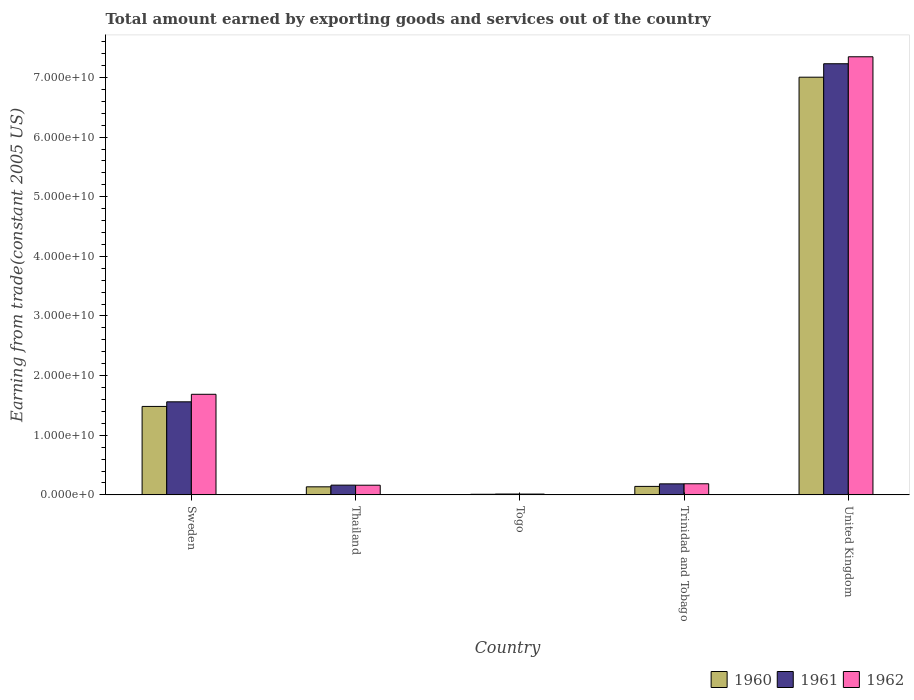How many groups of bars are there?
Ensure brevity in your answer.  5. How many bars are there on the 1st tick from the left?
Give a very brief answer. 3. How many bars are there on the 1st tick from the right?
Your response must be concise. 3. What is the label of the 3rd group of bars from the left?
Give a very brief answer. Togo. In how many cases, is the number of bars for a given country not equal to the number of legend labels?
Your answer should be very brief. 0. What is the total amount earned by exporting goods and services in 1961 in United Kingdom?
Your response must be concise. 7.23e+1. Across all countries, what is the maximum total amount earned by exporting goods and services in 1960?
Offer a terse response. 7.00e+1. Across all countries, what is the minimum total amount earned by exporting goods and services in 1960?
Give a very brief answer. 1.04e+08. In which country was the total amount earned by exporting goods and services in 1962 maximum?
Provide a short and direct response. United Kingdom. In which country was the total amount earned by exporting goods and services in 1960 minimum?
Ensure brevity in your answer.  Togo. What is the total total amount earned by exporting goods and services in 1962 in the graph?
Provide a succinct answer. 9.40e+1. What is the difference between the total amount earned by exporting goods and services in 1961 in Sweden and that in Togo?
Give a very brief answer. 1.55e+1. What is the difference between the total amount earned by exporting goods and services in 1961 in United Kingdom and the total amount earned by exporting goods and services in 1962 in Sweden?
Your answer should be compact. 5.54e+1. What is the average total amount earned by exporting goods and services in 1961 per country?
Keep it short and to the point. 1.83e+1. What is the difference between the total amount earned by exporting goods and services of/in 1961 and total amount earned by exporting goods and services of/in 1962 in Thailand?
Your response must be concise. 1.49e+07. What is the ratio of the total amount earned by exporting goods and services in 1961 in Sweden to that in Trinidad and Tobago?
Make the answer very short. 8.43. Is the total amount earned by exporting goods and services in 1961 in Togo less than that in United Kingdom?
Offer a terse response. Yes. Is the difference between the total amount earned by exporting goods and services in 1961 in Togo and United Kingdom greater than the difference between the total amount earned by exporting goods and services in 1962 in Togo and United Kingdom?
Give a very brief answer. Yes. What is the difference between the highest and the second highest total amount earned by exporting goods and services in 1962?
Give a very brief answer. -1.50e+1. What is the difference between the highest and the lowest total amount earned by exporting goods and services in 1960?
Provide a short and direct response. 6.99e+1. In how many countries, is the total amount earned by exporting goods and services in 1961 greater than the average total amount earned by exporting goods and services in 1961 taken over all countries?
Offer a very short reply. 1. Is the sum of the total amount earned by exporting goods and services in 1961 in Sweden and Thailand greater than the maximum total amount earned by exporting goods and services in 1960 across all countries?
Your response must be concise. No. How many bars are there?
Offer a terse response. 15. How many countries are there in the graph?
Your response must be concise. 5. Are the values on the major ticks of Y-axis written in scientific E-notation?
Keep it short and to the point. Yes. Does the graph contain any zero values?
Offer a terse response. No. Where does the legend appear in the graph?
Make the answer very short. Bottom right. What is the title of the graph?
Provide a short and direct response. Total amount earned by exporting goods and services out of the country. What is the label or title of the X-axis?
Offer a very short reply. Country. What is the label or title of the Y-axis?
Your answer should be compact. Earning from trade(constant 2005 US). What is the Earning from trade(constant 2005 US) of 1960 in Sweden?
Keep it short and to the point. 1.48e+1. What is the Earning from trade(constant 2005 US) of 1961 in Sweden?
Keep it short and to the point. 1.56e+1. What is the Earning from trade(constant 2005 US) of 1962 in Sweden?
Provide a short and direct response. 1.69e+1. What is the Earning from trade(constant 2005 US) of 1960 in Thailand?
Provide a short and direct response. 1.35e+09. What is the Earning from trade(constant 2005 US) in 1961 in Thailand?
Make the answer very short. 1.64e+09. What is the Earning from trade(constant 2005 US) of 1962 in Thailand?
Ensure brevity in your answer.  1.62e+09. What is the Earning from trade(constant 2005 US) in 1960 in Togo?
Give a very brief answer. 1.04e+08. What is the Earning from trade(constant 2005 US) of 1961 in Togo?
Keep it short and to the point. 1.46e+08. What is the Earning from trade(constant 2005 US) of 1962 in Togo?
Give a very brief answer. 1.39e+08. What is the Earning from trade(constant 2005 US) of 1960 in Trinidad and Tobago?
Give a very brief answer. 1.42e+09. What is the Earning from trade(constant 2005 US) in 1961 in Trinidad and Tobago?
Offer a very short reply. 1.85e+09. What is the Earning from trade(constant 2005 US) of 1962 in Trinidad and Tobago?
Provide a short and direct response. 1.86e+09. What is the Earning from trade(constant 2005 US) of 1960 in United Kingdom?
Offer a very short reply. 7.00e+1. What is the Earning from trade(constant 2005 US) of 1961 in United Kingdom?
Give a very brief answer. 7.23e+1. What is the Earning from trade(constant 2005 US) in 1962 in United Kingdom?
Give a very brief answer. 7.35e+1. Across all countries, what is the maximum Earning from trade(constant 2005 US) in 1960?
Your answer should be compact. 7.00e+1. Across all countries, what is the maximum Earning from trade(constant 2005 US) in 1961?
Your answer should be compact. 7.23e+1. Across all countries, what is the maximum Earning from trade(constant 2005 US) in 1962?
Provide a short and direct response. 7.35e+1. Across all countries, what is the minimum Earning from trade(constant 2005 US) of 1960?
Provide a succinct answer. 1.04e+08. Across all countries, what is the minimum Earning from trade(constant 2005 US) of 1961?
Your response must be concise. 1.46e+08. Across all countries, what is the minimum Earning from trade(constant 2005 US) of 1962?
Provide a succinct answer. 1.39e+08. What is the total Earning from trade(constant 2005 US) in 1960 in the graph?
Ensure brevity in your answer.  8.78e+1. What is the total Earning from trade(constant 2005 US) in 1961 in the graph?
Offer a very short reply. 9.15e+1. What is the total Earning from trade(constant 2005 US) of 1962 in the graph?
Your answer should be very brief. 9.40e+1. What is the difference between the Earning from trade(constant 2005 US) in 1960 in Sweden and that in Thailand?
Provide a succinct answer. 1.35e+1. What is the difference between the Earning from trade(constant 2005 US) in 1961 in Sweden and that in Thailand?
Your answer should be very brief. 1.40e+1. What is the difference between the Earning from trade(constant 2005 US) of 1962 in Sweden and that in Thailand?
Keep it short and to the point. 1.52e+1. What is the difference between the Earning from trade(constant 2005 US) in 1960 in Sweden and that in Togo?
Your response must be concise. 1.47e+1. What is the difference between the Earning from trade(constant 2005 US) in 1961 in Sweden and that in Togo?
Your answer should be very brief. 1.55e+1. What is the difference between the Earning from trade(constant 2005 US) in 1962 in Sweden and that in Togo?
Your answer should be compact. 1.67e+1. What is the difference between the Earning from trade(constant 2005 US) of 1960 in Sweden and that in Trinidad and Tobago?
Your answer should be very brief. 1.34e+1. What is the difference between the Earning from trade(constant 2005 US) of 1961 in Sweden and that in Trinidad and Tobago?
Ensure brevity in your answer.  1.38e+1. What is the difference between the Earning from trade(constant 2005 US) in 1962 in Sweden and that in Trinidad and Tobago?
Offer a very short reply. 1.50e+1. What is the difference between the Earning from trade(constant 2005 US) in 1960 in Sweden and that in United Kingdom?
Keep it short and to the point. -5.52e+1. What is the difference between the Earning from trade(constant 2005 US) of 1961 in Sweden and that in United Kingdom?
Make the answer very short. -5.67e+1. What is the difference between the Earning from trade(constant 2005 US) in 1962 in Sweden and that in United Kingdom?
Your answer should be compact. -5.66e+1. What is the difference between the Earning from trade(constant 2005 US) in 1960 in Thailand and that in Togo?
Ensure brevity in your answer.  1.25e+09. What is the difference between the Earning from trade(constant 2005 US) in 1961 in Thailand and that in Togo?
Provide a succinct answer. 1.49e+09. What is the difference between the Earning from trade(constant 2005 US) in 1962 in Thailand and that in Togo?
Your answer should be compact. 1.48e+09. What is the difference between the Earning from trade(constant 2005 US) of 1960 in Thailand and that in Trinidad and Tobago?
Your answer should be very brief. -6.88e+07. What is the difference between the Earning from trade(constant 2005 US) of 1961 in Thailand and that in Trinidad and Tobago?
Your response must be concise. -2.13e+08. What is the difference between the Earning from trade(constant 2005 US) of 1962 in Thailand and that in Trinidad and Tobago?
Offer a terse response. -2.41e+08. What is the difference between the Earning from trade(constant 2005 US) in 1960 in Thailand and that in United Kingdom?
Your answer should be compact. -6.87e+1. What is the difference between the Earning from trade(constant 2005 US) of 1961 in Thailand and that in United Kingdom?
Give a very brief answer. -7.07e+1. What is the difference between the Earning from trade(constant 2005 US) of 1962 in Thailand and that in United Kingdom?
Offer a terse response. -7.18e+1. What is the difference between the Earning from trade(constant 2005 US) of 1960 in Togo and that in Trinidad and Tobago?
Keep it short and to the point. -1.32e+09. What is the difference between the Earning from trade(constant 2005 US) in 1961 in Togo and that in Trinidad and Tobago?
Keep it short and to the point. -1.70e+09. What is the difference between the Earning from trade(constant 2005 US) in 1962 in Togo and that in Trinidad and Tobago?
Keep it short and to the point. -1.73e+09. What is the difference between the Earning from trade(constant 2005 US) in 1960 in Togo and that in United Kingdom?
Provide a short and direct response. -6.99e+1. What is the difference between the Earning from trade(constant 2005 US) in 1961 in Togo and that in United Kingdom?
Provide a short and direct response. -7.22e+1. What is the difference between the Earning from trade(constant 2005 US) in 1962 in Togo and that in United Kingdom?
Provide a short and direct response. -7.33e+1. What is the difference between the Earning from trade(constant 2005 US) of 1960 in Trinidad and Tobago and that in United Kingdom?
Provide a succinct answer. -6.86e+1. What is the difference between the Earning from trade(constant 2005 US) of 1961 in Trinidad and Tobago and that in United Kingdom?
Give a very brief answer. -7.04e+1. What is the difference between the Earning from trade(constant 2005 US) of 1962 in Trinidad and Tobago and that in United Kingdom?
Provide a short and direct response. -7.16e+1. What is the difference between the Earning from trade(constant 2005 US) of 1960 in Sweden and the Earning from trade(constant 2005 US) of 1961 in Thailand?
Give a very brief answer. 1.32e+1. What is the difference between the Earning from trade(constant 2005 US) in 1960 in Sweden and the Earning from trade(constant 2005 US) in 1962 in Thailand?
Keep it short and to the point. 1.32e+1. What is the difference between the Earning from trade(constant 2005 US) of 1961 in Sweden and the Earning from trade(constant 2005 US) of 1962 in Thailand?
Offer a terse response. 1.40e+1. What is the difference between the Earning from trade(constant 2005 US) of 1960 in Sweden and the Earning from trade(constant 2005 US) of 1961 in Togo?
Give a very brief answer. 1.47e+1. What is the difference between the Earning from trade(constant 2005 US) of 1960 in Sweden and the Earning from trade(constant 2005 US) of 1962 in Togo?
Make the answer very short. 1.47e+1. What is the difference between the Earning from trade(constant 2005 US) in 1961 in Sweden and the Earning from trade(constant 2005 US) in 1962 in Togo?
Provide a short and direct response. 1.55e+1. What is the difference between the Earning from trade(constant 2005 US) in 1960 in Sweden and the Earning from trade(constant 2005 US) in 1961 in Trinidad and Tobago?
Ensure brevity in your answer.  1.30e+1. What is the difference between the Earning from trade(constant 2005 US) of 1960 in Sweden and the Earning from trade(constant 2005 US) of 1962 in Trinidad and Tobago?
Ensure brevity in your answer.  1.30e+1. What is the difference between the Earning from trade(constant 2005 US) of 1961 in Sweden and the Earning from trade(constant 2005 US) of 1962 in Trinidad and Tobago?
Offer a terse response. 1.37e+1. What is the difference between the Earning from trade(constant 2005 US) of 1960 in Sweden and the Earning from trade(constant 2005 US) of 1961 in United Kingdom?
Your answer should be compact. -5.75e+1. What is the difference between the Earning from trade(constant 2005 US) of 1960 in Sweden and the Earning from trade(constant 2005 US) of 1962 in United Kingdom?
Keep it short and to the point. -5.86e+1. What is the difference between the Earning from trade(constant 2005 US) in 1961 in Sweden and the Earning from trade(constant 2005 US) in 1962 in United Kingdom?
Your response must be concise. -5.79e+1. What is the difference between the Earning from trade(constant 2005 US) of 1960 in Thailand and the Earning from trade(constant 2005 US) of 1961 in Togo?
Offer a terse response. 1.21e+09. What is the difference between the Earning from trade(constant 2005 US) of 1960 in Thailand and the Earning from trade(constant 2005 US) of 1962 in Togo?
Ensure brevity in your answer.  1.22e+09. What is the difference between the Earning from trade(constant 2005 US) in 1961 in Thailand and the Earning from trade(constant 2005 US) in 1962 in Togo?
Provide a short and direct response. 1.50e+09. What is the difference between the Earning from trade(constant 2005 US) in 1960 in Thailand and the Earning from trade(constant 2005 US) in 1961 in Trinidad and Tobago?
Ensure brevity in your answer.  -4.96e+08. What is the difference between the Earning from trade(constant 2005 US) in 1960 in Thailand and the Earning from trade(constant 2005 US) in 1962 in Trinidad and Tobago?
Your answer should be very brief. -5.09e+08. What is the difference between the Earning from trade(constant 2005 US) of 1961 in Thailand and the Earning from trade(constant 2005 US) of 1962 in Trinidad and Tobago?
Keep it short and to the point. -2.26e+08. What is the difference between the Earning from trade(constant 2005 US) in 1960 in Thailand and the Earning from trade(constant 2005 US) in 1961 in United Kingdom?
Provide a succinct answer. -7.09e+1. What is the difference between the Earning from trade(constant 2005 US) of 1960 in Thailand and the Earning from trade(constant 2005 US) of 1962 in United Kingdom?
Offer a very short reply. -7.21e+1. What is the difference between the Earning from trade(constant 2005 US) of 1961 in Thailand and the Earning from trade(constant 2005 US) of 1962 in United Kingdom?
Offer a terse response. -7.18e+1. What is the difference between the Earning from trade(constant 2005 US) in 1960 in Togo and the Earning from trade(constant 2005 US) in 1961 in Trinidad and Tobago?
Provide a short and direct response. -1.75e+09. What is the difference between the Earning from trade(constant 2005 US) in 1960 in Togo and the Earning from trade(constant 2005 US) in 1962 in Trinidad and Tobago?
Give a very brief answer. -1.76e+09. What is the difference between the Earning from trade(constant 2005 US) in 1961 in Togo and the Earning from trade(constant 2005 US) in 1962 in Trinidad and Tobago?
Ensure brevity in your answer.  -1.72e+09. What is the difference between the Earning from trade(constant 2005 US) in 1960 in Togo and the Earning from trade(constant 2005 US) in 1961 in United Kingdom?
Your response must be concise. -7.22e+1. What is the difference between the Earning from trade(constant 2005 US) of 1960 in Togo and the Earning from trade(constant 2005 US) of 1962 in United Kingdom?
Make the answer very short. -7.34e+1. What is the difference between the Earning from trade(constant 2005 US) of 1961 in Togo and the Earning from trade(constant 2005 US) of 1962 in United Kingdom?
Your answer should be compact. -7.33e+1. What is the difference between the Earning from trade(constant 2005 US) in 1960 in Trinidad and Tobago and the Earning from trade(constant 2005 US) in 1961 in United Kingdom?
Offer a terse response. -7.09e+1. What is the difference between the Earning from trade(constant 2005 US) of 1960 in Trinidad and Tobago and the Earning from trade(constant 2005 US) of 1962 in United Kingdom?
Ensure brevity in your answer.  -7.20e+1. What is the difference between the Earning from trade(constant 2005 US) in 1961 in Trinidad and Tobago and the Earning from trade(constant 2005 US) in 1962 in United Kingdom?
Your answer should be very brief. -7.16e+1. What is the average Earning from trade(constant 2005 US) of 1960 per country?
Your answer should be compact. 1.76e+1. What is the average Earning from trade(constant 2005 US) in 1961 per country?
Your answer should be very brief. 1.83e+1. What is the average Earning from trade(constant 2005 US) in 1962 per country?
Your answer should be compact. 1.88e+1. What is the difference between the Earning from trade(constant 2005 US) in 1960 and Earning from trade(constant 2005 US) in 1961 in Sweden?
Provide a succinct answer. -7.72e+08. What is the difference between the Earning from trade(constant 2005 US) of 1960 and Earning from trade(constant 2005 US) of 1962 in Sweden?
Provide a succinct answer. -2.03e+09. What is the difference between the Earning from trade(constant 2005 US) of 1961 and Earning from trade(constant 2005 US) of 1962 in Sweden?
Offer a terse response. -1.26e+09. What is the difference between the Earning from trade(constant 2005 US) of 1960 and Earning from trade(constant 2005 US) of 1961 in Thailand?
Provide a succinct answer. -2.83e+08. What is the difference between the Earning from trade(constant 2005 US) of 1960 and Earning from trade(constant 2005 US) of 1962 in Thailand?
Provide a short and direct response. -2.68e+08. What is the difference between the Earning from trade(constant 2005 US) of 1961 and Earning from trade(constant 2005 US) of 1962 in Thailand?
Your answer should be very brief. 1.49e+07. What is the difference between the Earning from trade(constant 2005 US) of 1960 and Earning from trade(constant 2005 US) of 1961 in Togo?
Ensure brevity in your answer.  -4.26e+07. What is the difference between the Earning from trade(constant 2005 US) in 1960 and Earning from trade(constant 2005 US) in 1962 in Togo?
Offer a very short reply. -3.51e+07. What is the difference between the Earning from trade(constant 2005 US) in 1961 and Earning from trade(constant 2005 US) in 1962 in Togo?
Give a very brief answer. 7.52e+06. What is the difference between the Earning from trade(constant 2005 US) of 1960 and Earning from trade(constant 2005 US) of 1961 in Trinidad and Tobago?
Provide a short and direct response. -4.27e+08. What is the difference between the Earning from trade(constant 2005 US) of 1960 and Earning from trade(constant 2005 US) of 1962 in Trinidad and Tobago?
Your answer should be very brief. -4.40e+08. What is the difference between the Earning from trade(constant 2005 US) in 1961 and Earning from trade(constant 2005 US) in 1962 in Trinidad and Tobago?
Offer a very short reply. -1.34e+07. What is the difference between the Earning from trade(constant 2005 US) in 1960 and Earning from trade(constant 2005 US) in 1961 in United Kingdom?
Ensure brevity in your answer.  -2.26e+09. What is the difference between the Earning from trade(constant 2005 US) of 1960 and Earning from trade(constant 2005 US) of 1962 in United Kingdom?
Give a very brief answer. -3.42e+09. What is the difference between the Earning from trade(constant 2005 US) in 1961 and Earning from trade(constant 2005 US) in 1962 in United Kingdom?
Your answer should be compact. -1.17e+09. What is the ratio of the Earning from trade(constant 2005 US) in 1960 in Sweden to that in Thailand?
Your response must be concise. 10.95. What is the ratio of the Earning from trade(constant 2005 US) of 1961 in Sweden to that in Thailand?
Keep it short and to the point. 9.53. What is the ratio of the Earning from trade(constant 2005 US) of 1962 in Sweden to that in Thailand?
Your response must be concise. 10.4. What is the ratio of the Earning from trade(constant 2005 US) in 1960 in Sweden to that in Togo?
Your answer should be compact. 142.92. What is the ratio of the Earning from trade(constant 2005 US) in 1961 in Sweden to that in Togo?
Your response must be concise. 106.59. What is the ratio of the Earning from trade(constant 2005 US) in 1962 in Sweden to that in Togo?
Your answer should be very brief. 121.45. What is the ratio of the Earning from trade(constant 2005 US) in 1960 in Sweden to that in Trinidad and Tobago?
Give a very brief answer. 10.42. What is the ratio of the Earning from trade(constant 2005 US) of 1961 in Sweden to that in Trinidad and Tobago?
Your answer should be compact. 8.43. What is the ratio of the Earning from trade(constant 2005 US) in 1962 in Sweden to that in Trinidad and Tobago?
Offer a very short reply. 9.05. What is the ratio of the Earning from trade(constant 2005 US) of 1960 in Sweden to that in United Kingdom?
Your response must be concise. 0.21. What is the ratio of the Earning from trade(constant 2005 US) in 1961 in Sweden to that in United Kingdom?
Offer a terse response. 0.22. What is the ratio of the Earning from trade(constant 2005 US) of 1962 in Sweden to that in United Kingdom?
Your answer should be very brief. 0.23. What is the ratio of the Earning from trade(constant 2005 US) in 1960 in Thailand to that in Togo?
Provide a succinct answer. 13.05. What is the ratio of the Earning from trade(constant 2005 US) of 1961 in Thailand to that in Togo?
Your answer should be compact. 11.18. What is the ratio of the Earning from trade(constant 2005 US) of 1962 in Thailand to that in Togo?
Keep it short and to the point. 11.68. What is the ratio of the Earning from trade(constant 2005 US) of 1960 in Thailand to that in Trinidad and Tobago?
Provide a short and direct response. 0.95. What is the ratio of the Earning from trade(constant 2005 US) of 1961 in Thailand to that in Trinidad and Tobago?
Your response must be concise. 0.88. What is the ratio of the Earning from trade(constant 2005 US) of 1962 in Thailand to that in Trinidad and Tobago?
Offer a very short reply. 0.87. What is the ratio of the Earning from trade(constant 2005 US) of 1960 in Thailand to that in United Kingdom?
Offer a very short reply. 0.02. What is the ratio of the Earning from trade(constant 2005 US) of 1961 in Thailand to that in United Kingdom?
Offer a very short reply. 0.02. What is the ratio of the Earning from trade(constant 2005 US) of 1962 in Thailand to that in United Kingdom?
Offer a very short reply. 0.02. What is the ratio of the Earning from trade(constant 2005 US) in 1960 in Togo to that in Trinidad and Tobago?
Offer a very short reply. 0.07. What is the ratio of the Earning from trade(constant 2005 US) of 1961 in Togo to that in Trinidad and Tobago?
Provide a short and direct response. 0.08. What is the ratio of the Earning from trade(constant 2005 US) in 1962 in Togo to that in Trinidad and Tobago?
Ensure brevity in your answer.  0.07. What is the ratio of the Earning from trade(constant 2005 US) in 1960 in Togo to that in United Kingdom?
Your answer should be compact. 0. What is the ratio of the Earning from trade(constant 2005 US) of 1961 in Togo to that in United Kingdom?
Your response must be concise. 0. What is the ratio of the Earning from trade(constant 2005 US) in 1962 in Togo to that in United Kingdom?
Your answer should be very brief. 0. What is the ratio of the Earning from trade(constant 2005 US) in 1960 in Trinidad and Tobago to that in United Kingdom?
Provide a succinct answer. 0.02. What is the ratio of the Earning from trade(constant 2005 US) in 1961 in Trinidad and Tobago to that in United Kingdom?
Your answer should be compact. 0.03. What is the ratio of the Earning from trade(constant 2005 US) in 1962 in Trinidad and Tobago to that in United Kingdom?
Your response must be concise. 0.03. What is the difference between the highest and the second highest Earning from trade(constant 2005 US) in 1960?
Provide a short and direct response. 5.52e+1. What is the difference between the highest and the second highest Earning from trade(constant 2005 US) in 1961?
Give a very brief answer. 5.67e+1. What is the difference between the highest and the second highest Earning from trade(constant 2005 US) of 1962?
Make the answer very short. 5.66e+1. What is the difference between the highest and the lowest Earning from trade(constant 2005 US) of 1960?
Keep it short and to the point. 6.99e+1. What is the difference between the highest and the lowest Earning from trade(constant 2005 US) of 1961?
Offer a terse response. 7.22e+1. What is the difference between the highest and the lowest Earning from trade(constant 2005 US) in 1962?
Your answer should be compact. 7.33e+1. 